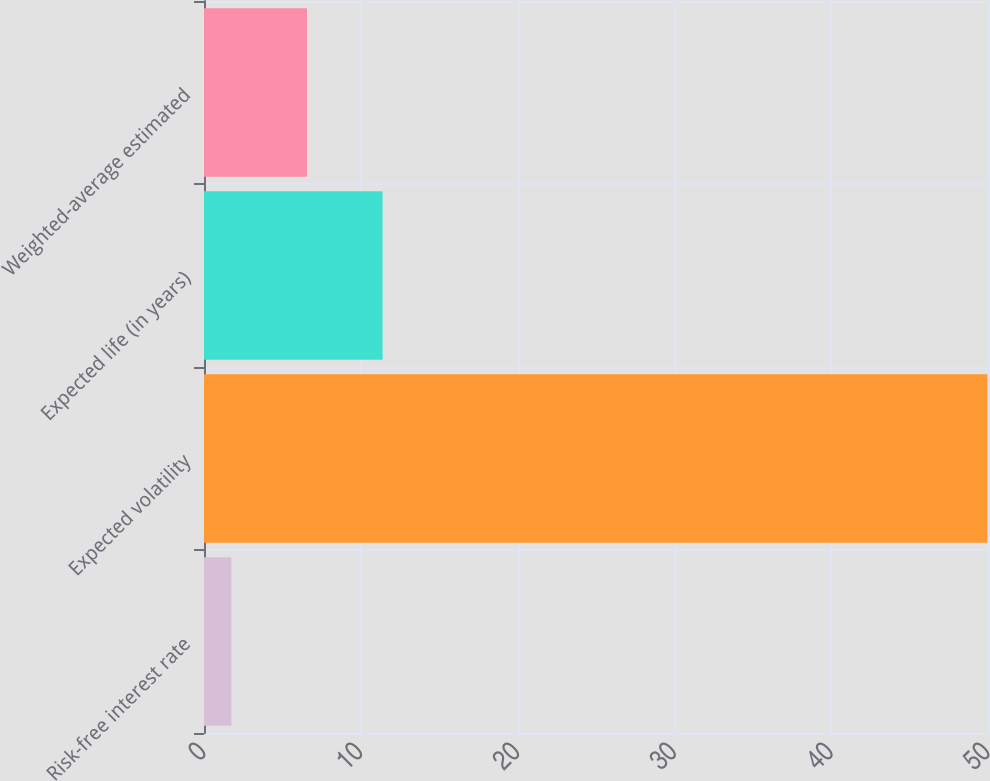Convert chart to OTSL. <chart><loc_0><loc_0><loc_500><loc_500><bar_chart><fcel>Risk-free interest rate<fcel>Expected volatility<fcel>Expected life (in years)<fcel>Weighted-average estimated<nl><fcel>1.75<fcel>49.96<fcel>11.39<fcel>6.57<nl></chart> 